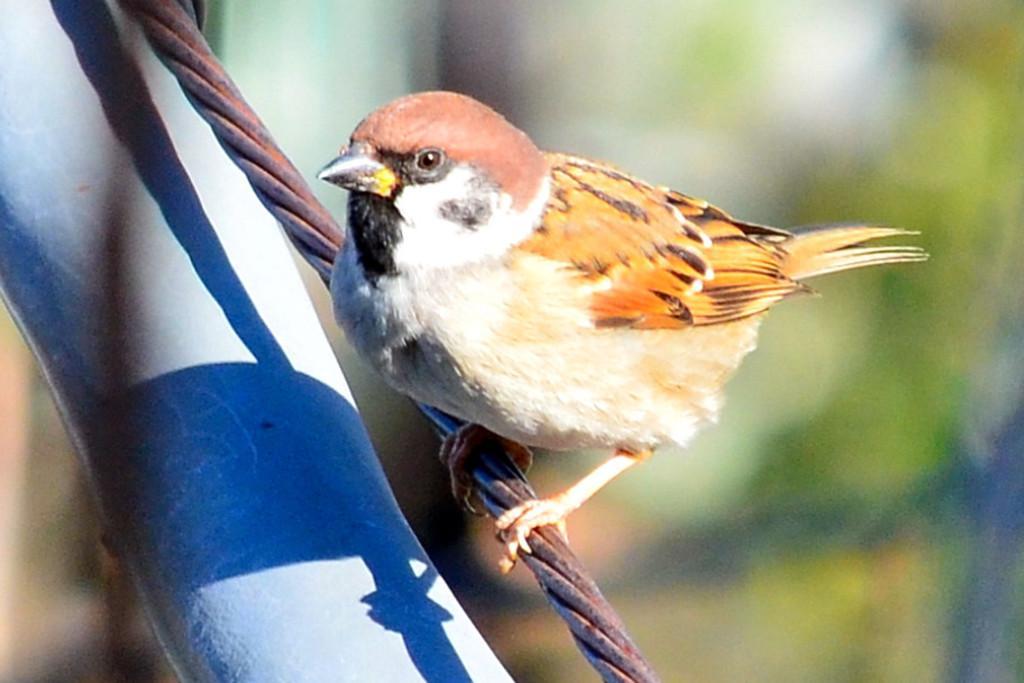Please provide a concise description of this image. In this image I can see the bird which is in cream, brown and black color. It is on the rope. I can see the white and blue color object in-front of the wall. And there is a blurred background. 